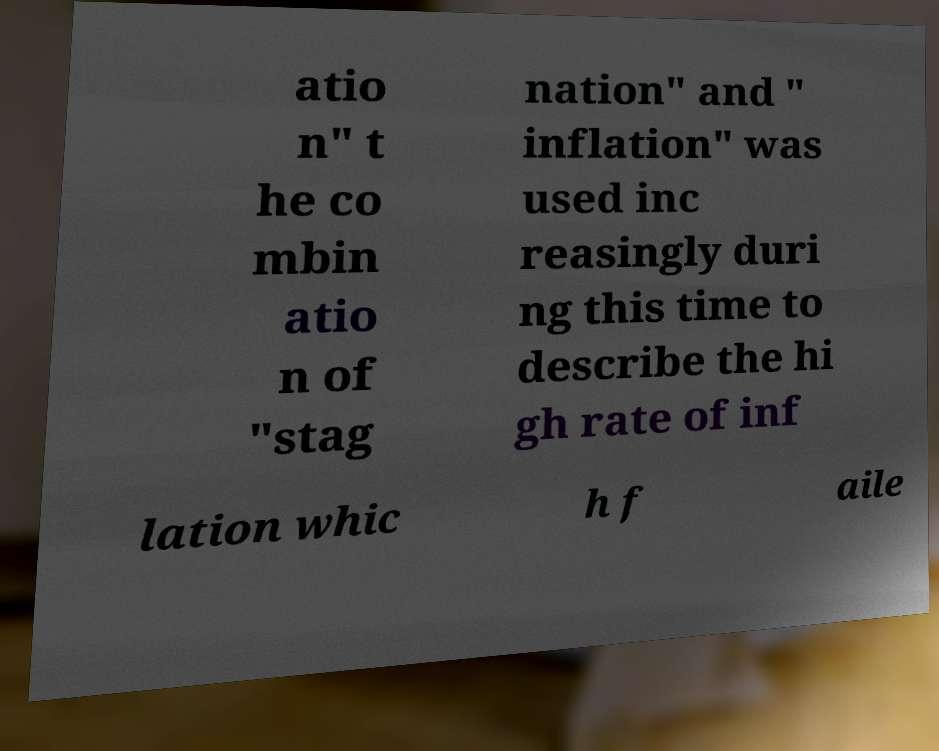Can you accurately transcribe the text from the provided image for me? atio n" t he co mbin atio n of "stag nation" and " inflation" was used inc reasingly duri ng this time to describe the hi gh rate of inf lation whic h f aile 